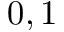Convert formula to latex. <formula><loc_0><loc_0><loc_500><loc_500>0 , 1</formula> 